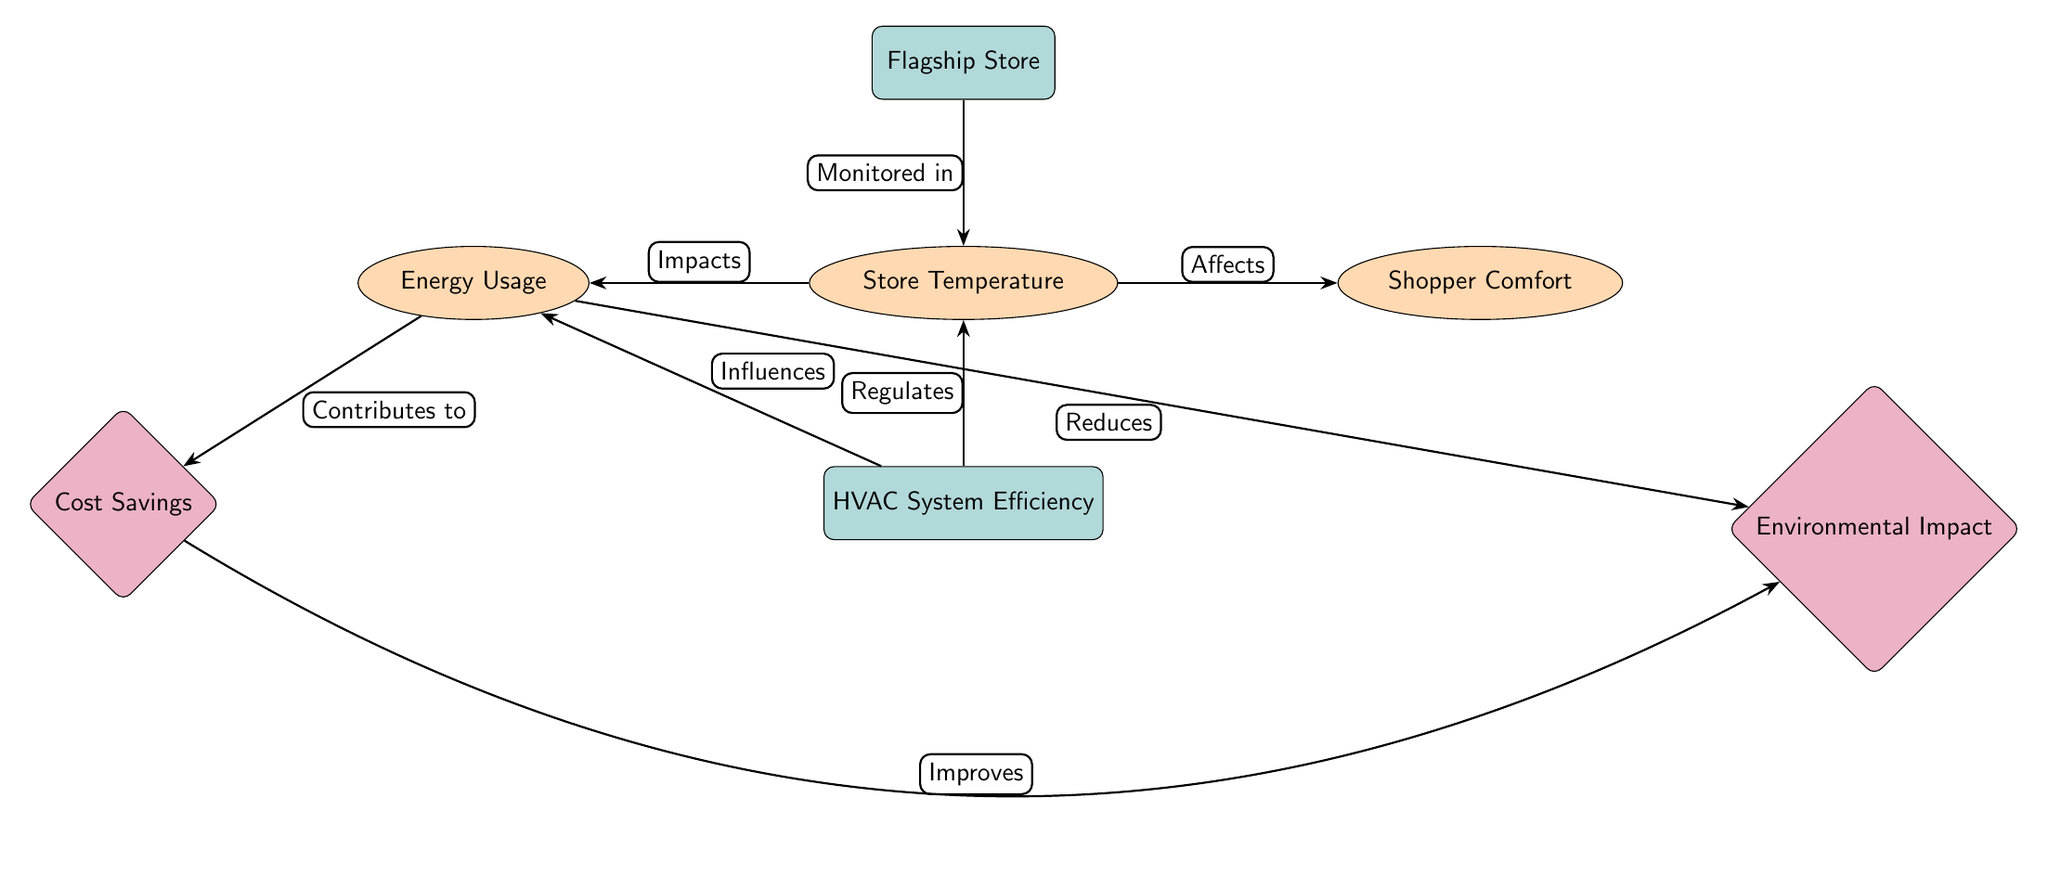What is the main subject of the diagram? The diagram centers on the "Flagship Store," which is indicated as the primary node at the top.
Answer: Flagship Store How many main nodes are present in the diagram? There are two main nodes: "Flagship Store" and "HVAC System Efficiency," representing the central concepts of the diagram.
Answer: 2 What is affected by the store temperature? The store temperature directly affects "Shopper Comfort," as illustrated by the arrow labeled "Affects" from "Store Temperature" to "Shopper Comfort."
Answer: Shopper Comfort What influences energy usage in the diagram? The "HVAC System Efficiency" node influences energy usage, as shown by the arrow labeled "Influences" pointing from it to "Energy Usage."
Answer: HVAC System Efficiency What component contributes to cost savings? The "Energy Usage" component contributes to cost savings, as indicated by the arrow labeled "Contributes to" from "Energy Usage" to "Cost Savings."
Answer: Energy Usage Which aspect reduces environmental impact? The environmental impact is reduced by "Energy Usage," as per the arrow labeled "Reduces" pointing from "Energy Usage" to "Environmental Impact."
Answer: Energy Usage How does the HVAC system impact store temperature? The diagram shows that the HVAC system regulates store temperature, as depicted by the arrow labeled "Regulates" from "HVAC System Efficiency" to "Store Temperature."
Answer: Regulates What is the relationship between energy usage and cost savings? Energy usage contributes to cost savings, illustrated by the connection labeled "Contributes to" between "Energy Usage" and "Cost Savings."
Answer: Contributes to How does store temperature influence both comfort and energy usage? Store temperature has a dual influence: it affects shopper comfort and also impacts energy usage, as indicated by separate connections to both "Shopper Comfort" and "Energy Usage."
Answer: Affects 